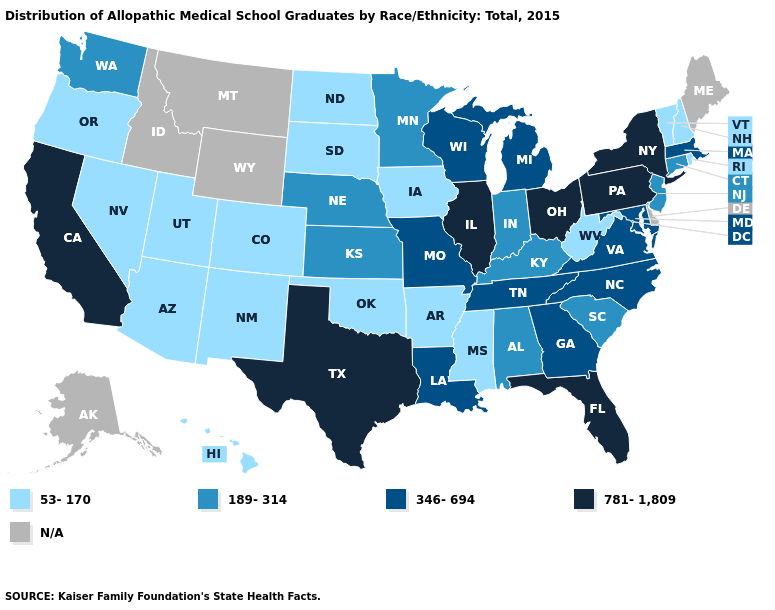Does the first symbol in the legend represent the smallest category?
Quick response, please. Yes. Does Nevada have the highest value in the USA?
Be succinct. No. Among the states that border Arizona , which have the lowest value?
Answer briefly. Colorado, Nevada, New Mexico, Utah. What is the value of New York?
Write a very short answer. 781-1,809. What is the highest value in the MidWest ?
Write a very short answer. 781-1,809. Does Arizona have the lowest value in the USA?
Write a very short answer. Yes. What is the value of Tennessee?
Answer briefly. 346-694. What is the value of Idaho?
Give a very brief answer. N/A. Name the states that have a value in the range N/A?
Keep it brief. Alaska, Delaware, Idaho, Maine, Montana, Wyoming. What is the value of Massachusetts?
Keep it brief. 346-694. What is the value of Georgia?
Keep it brief. 346-694. Is the legend a continuous bar?
Write a very short answer. No. Does West Virginia have the lowest value in the South?
Concise answer only. Yes. What is the value of Ohio?
Be succinct. 781-1,809. Which states have the lowest value in the MidWest?
Quick response, please. Iowa, North Dakota, South Dakota. 